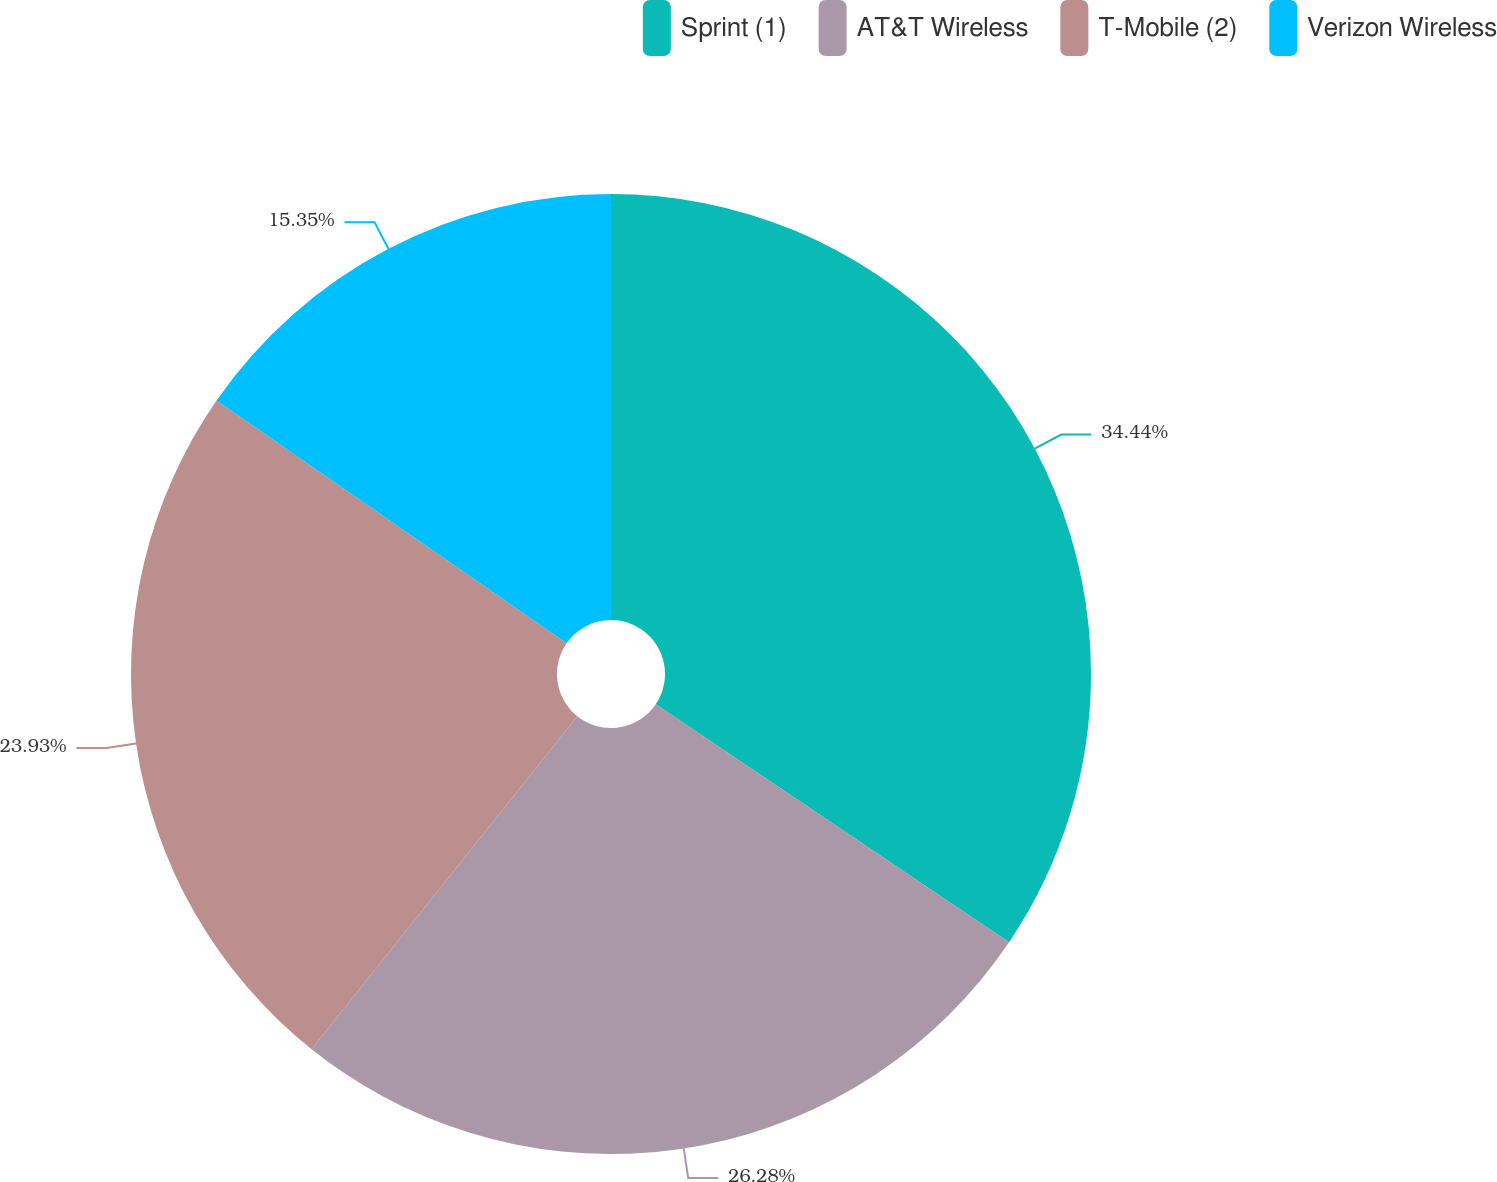Convert chart to OTSL. <chart><loc_0><loc_0><loc_500><loc_500><pie_chart><fcel>Sprint (1)<fcel>AT&T Wireless<fcel>T-Mobile (2)<fcel>Verizon Wireless<nl><fcel>34.44%<fcel>26.28%<fcel>23.93%<fcel>15.35%<nl></chart> 